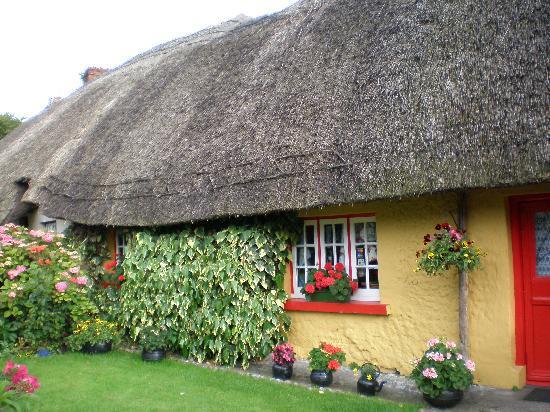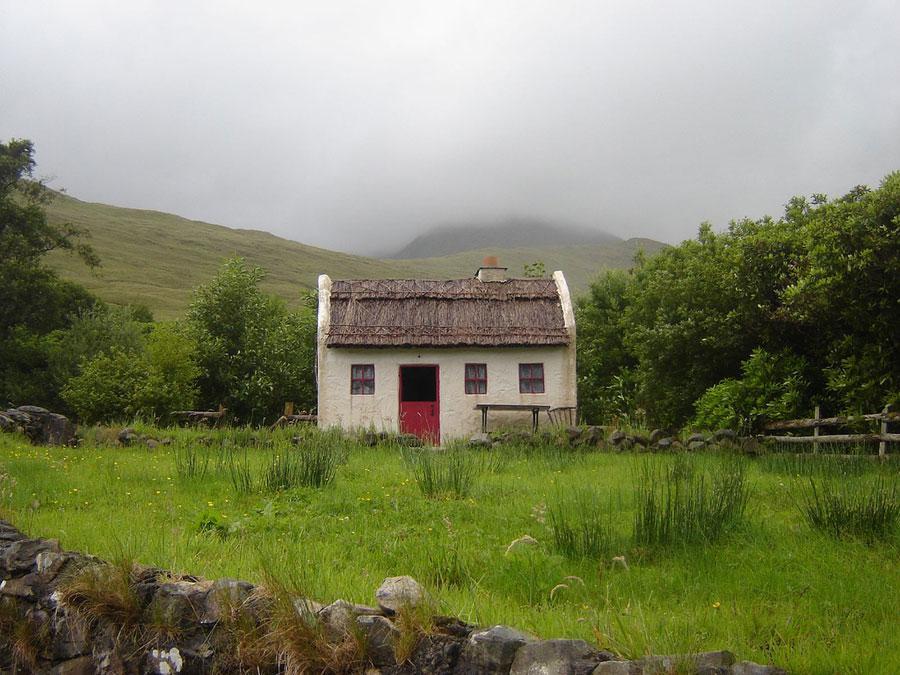The first image is the image on the left, the second image is the image on the right. Evaluate the accuracy of this statement regarding the images: "One of the houses has neither a red door nor red window trim.". Is it true? Answer yes or no. No. 